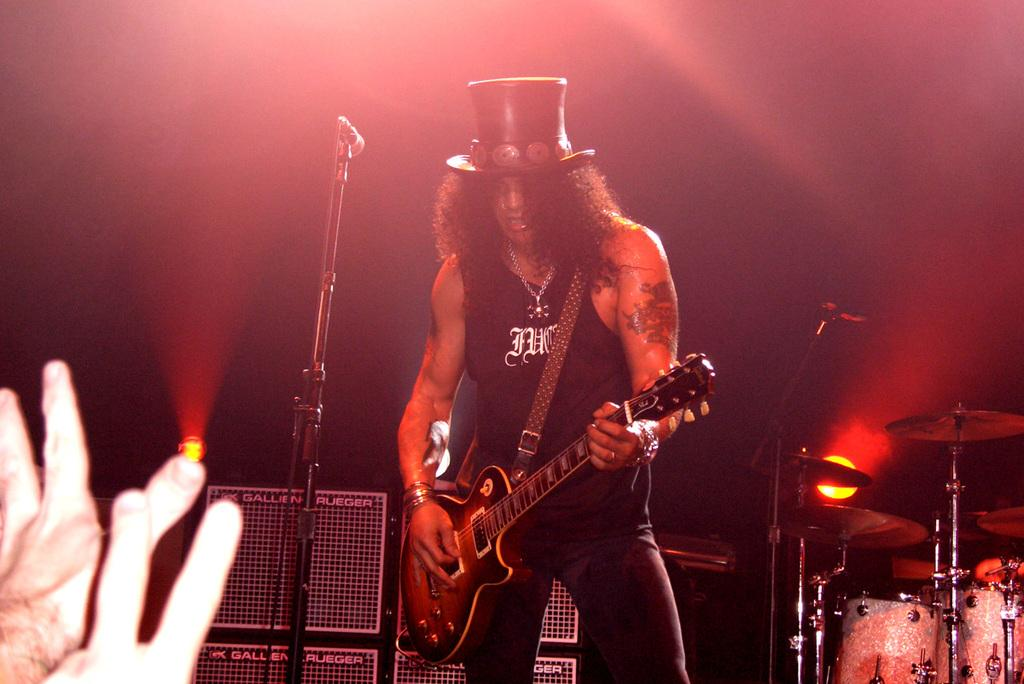What is the person in the image doing? The person is playing a guitar. What objects can be seen in the background of the image? There are speakers, a microphone, other people, drums, cymbals, and lights in the background of the image. What type of activity is taking place in the image? It appears to be a musical performance, given the presence of a guitar, drums, cymbals, and microphone. What type of plantation is visible in the image? There is no plantation present in the image. What are the chances of the person playing the guitar winning a writing contest? The image does not provide any information about the person's writing abilities or participation in a writing contest, so it is impossible to determine the chances of winning. 